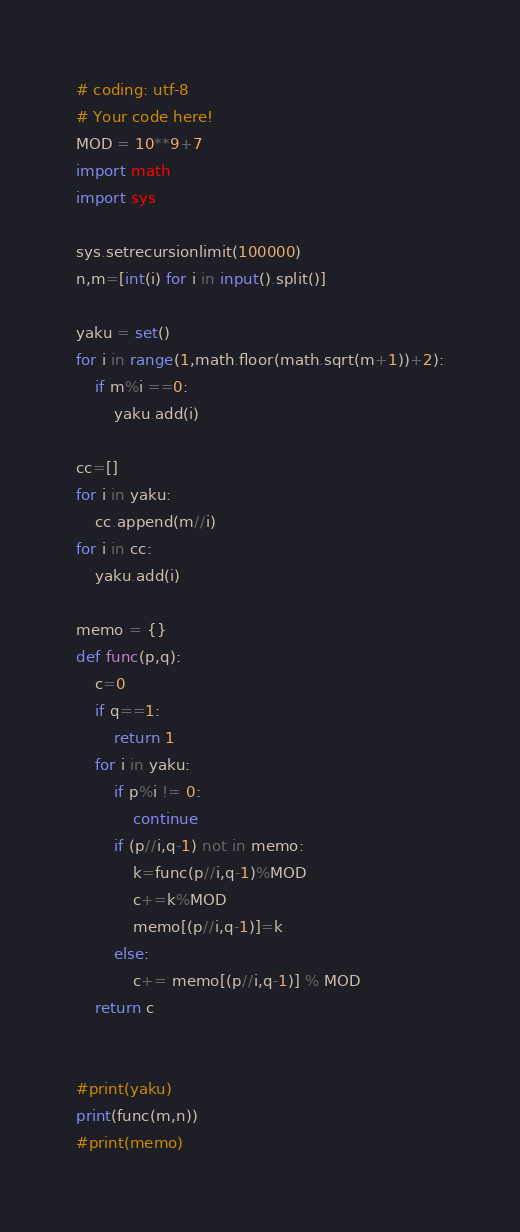Convert code to text. <code><loc_0><loc_0><loc_500><loc_500><_Python_># coding: utf-8
# Your code here!
MOD = 10**9+7
import math
import sys

sys.setrecursionlimit(100000)
n,m=[int(i) for i in input().split()]

yaku = set()
for i in range(1,math.floor(math.sqrt(m+1))+2):
    if m%i ==0:
        yaku.add(i)

cc=[]
for i in yaku:
    cc.append(m//i)
for i in cc:
    yaku.add(i)

memo = {}
def func(p,q):
    c=0
    if q==1:
        return 1
    for i in yaku:
        if p%i != 0:
            continue
        if (p//i,q-1) not in memo:
            k=func(p//i,q-1)%MOD
            c+=k%MOD
            memo[(p//i,q-1)]=k
        else: 
            c+= memo[(p//i,q-1)] % MOD
    return c
        
    
#print(yaku)
print(func(m,n))
#print(memo)



</code> 